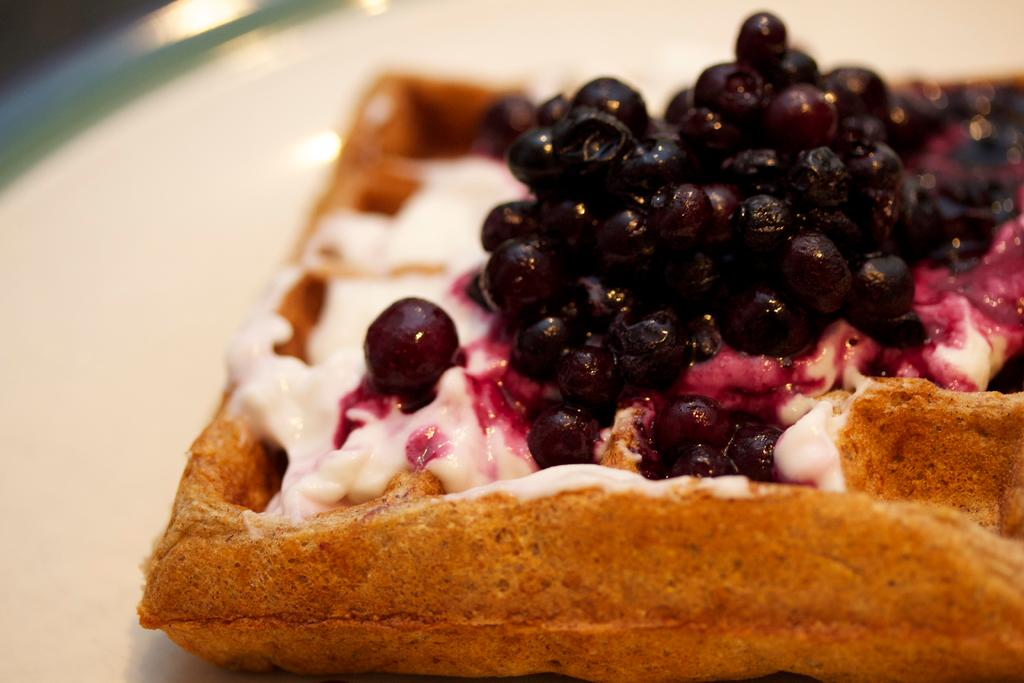What color is the plate in the image? The plate in the image is white colored. What is on the plate? There is a food item on the plate. Can you describe the colors of the food item? The food item has brown, white, pink, and black colors. What is the current condition of the plate in the image? There is no information about the current condition of the plate in the image. 